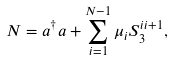<formula> <loc_0><loc_0><loc_500><loc_500>N = a ^ { \dagger } a + \sum _ { i = 1 } ^ { N - 1 } \mu _ { i } S _ { 3 } ^ { i i + 1 } ,</formula> 